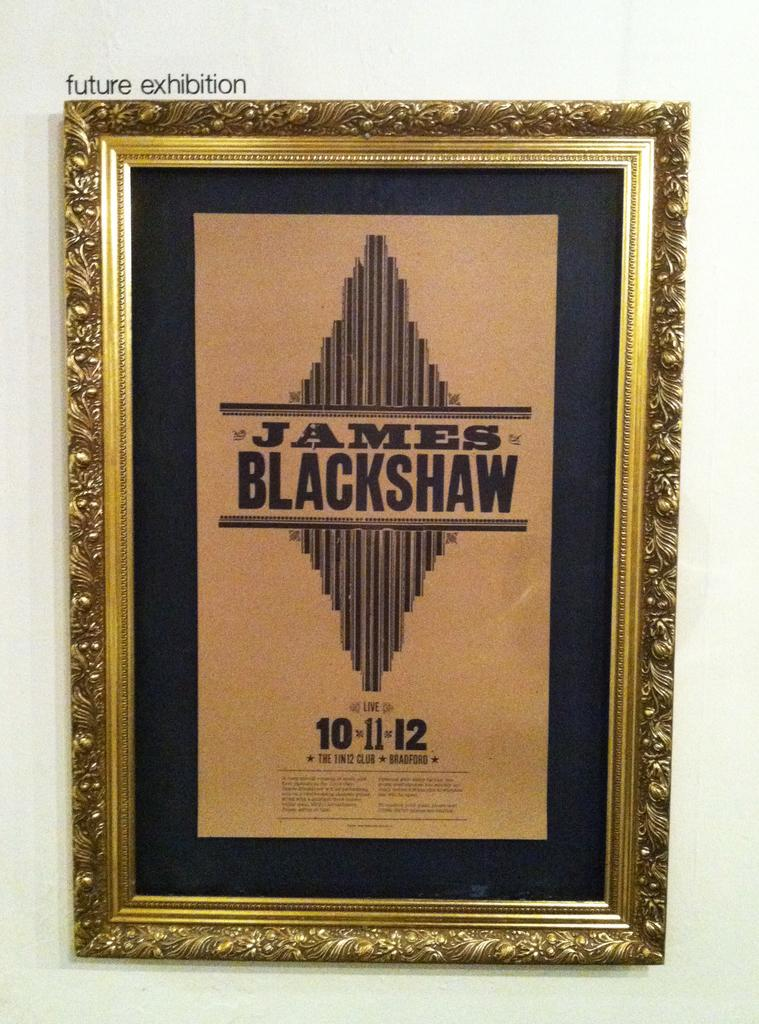<image>
Relay a brief, clear account of the picture shown. Poster framed on a wall titled "James Blackshaw". 